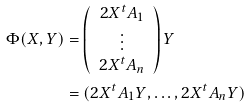<formula> <loc_0><loc_0><loc_500><loc_500>\Phi ( X , Y ) & = \left ( \begin{array} { c } 2 X ^ { t } A _ { 1 } \\ \vdots \\ 2 X ^ { t } A _ { n } \end{array} \right ) Y \\ & = ( 2 X ^ { t } A _ { 1 } Y , \dots , 2 X ^ { t } A _ { n } Y )</formula> 